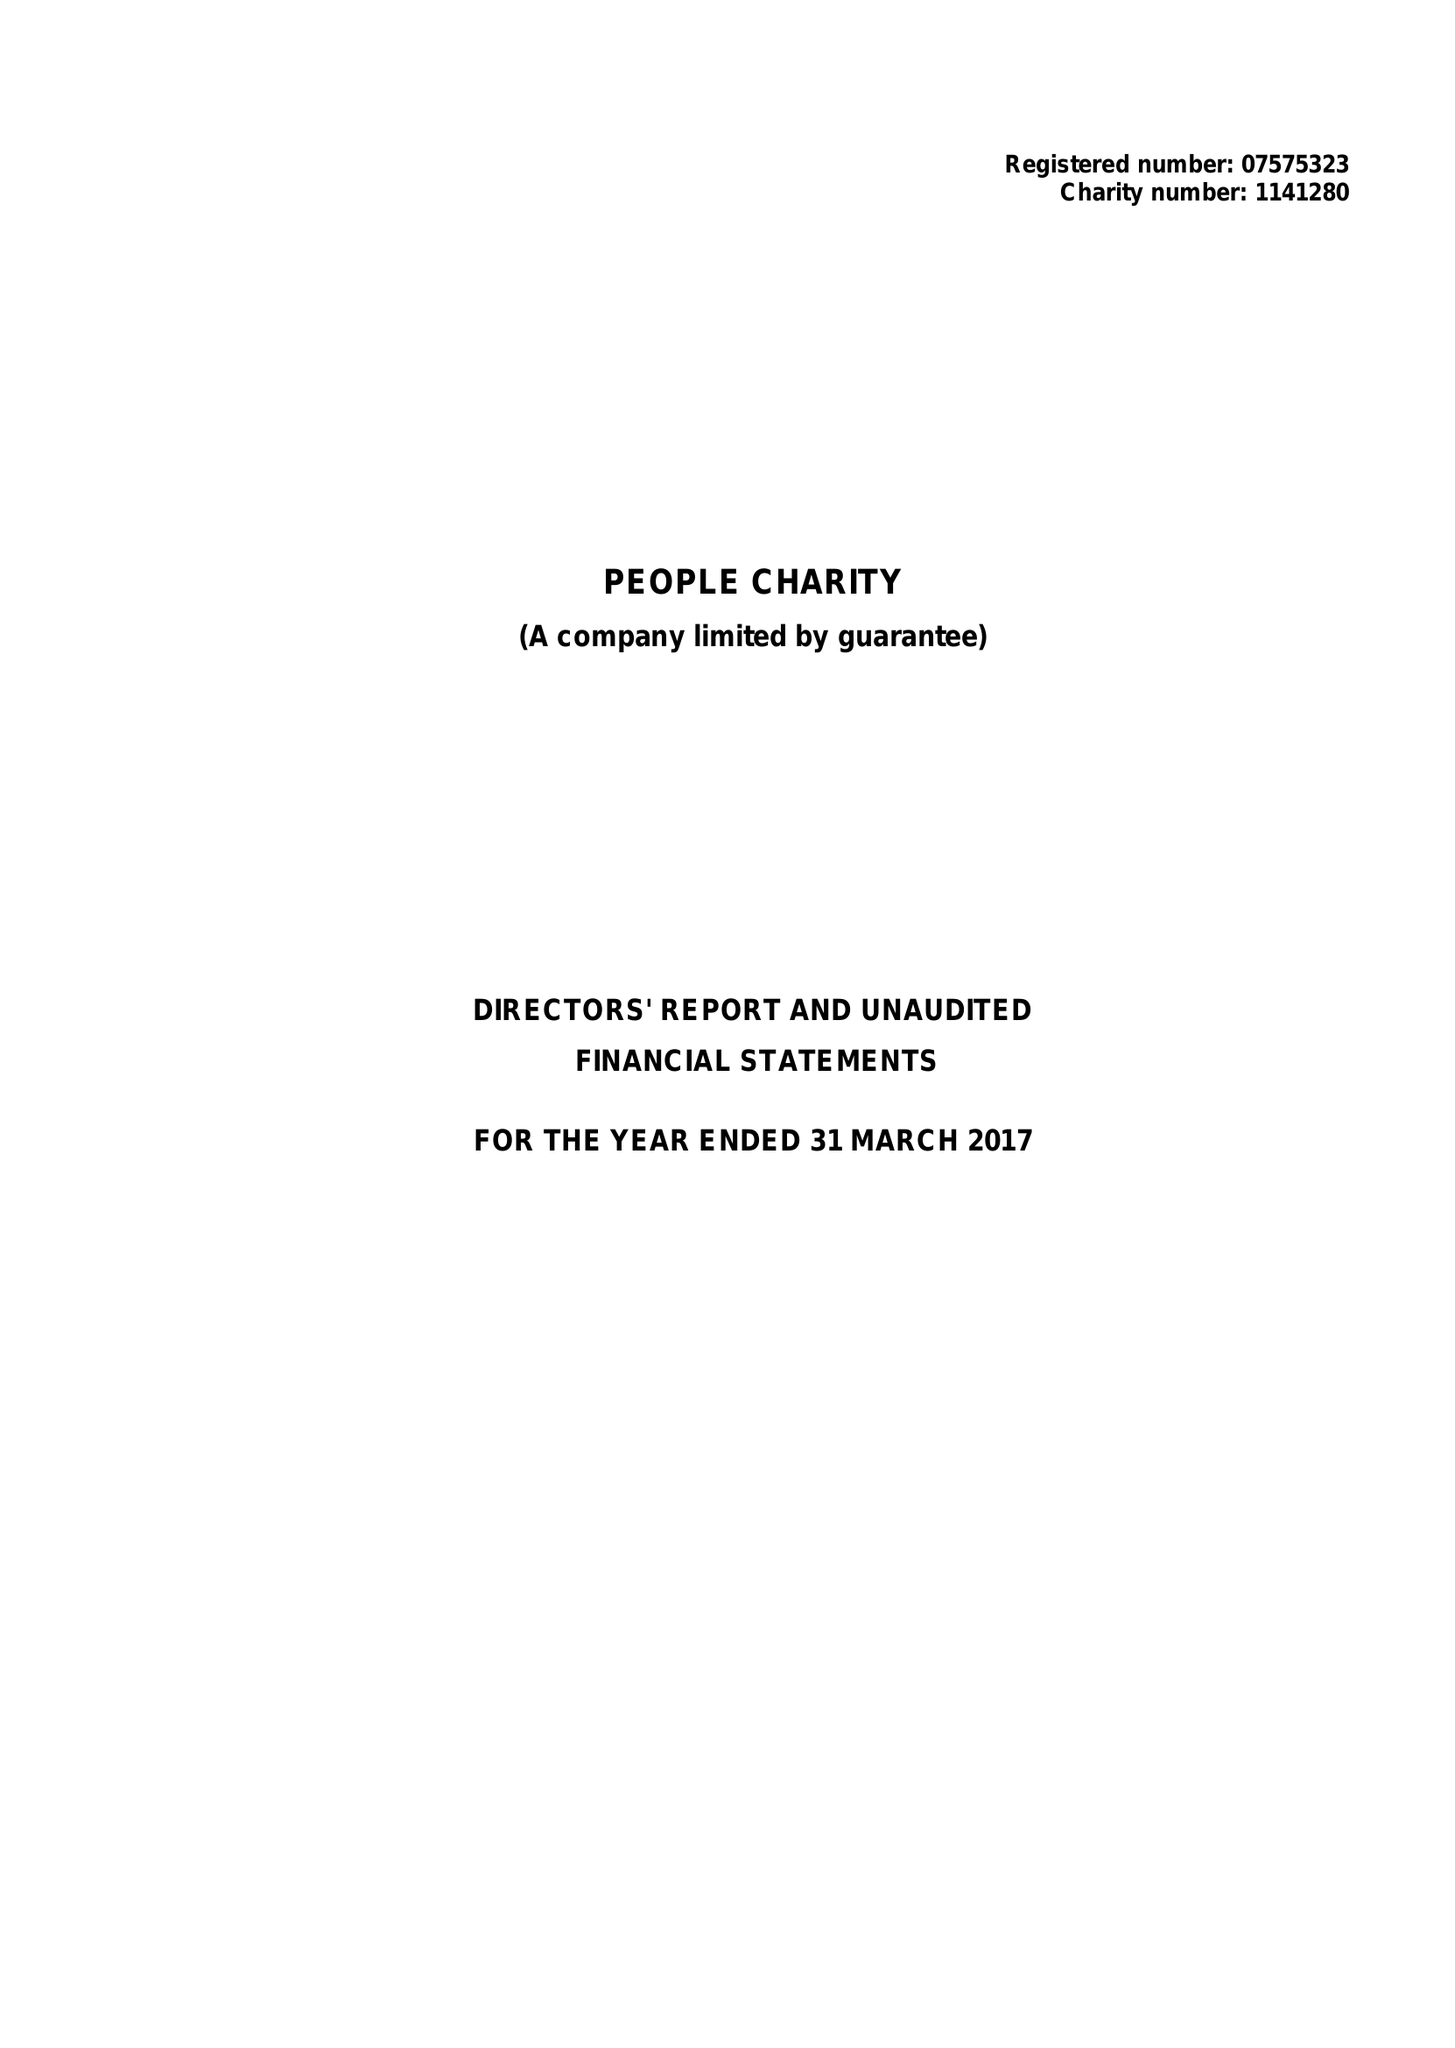What is the value for the charity_number?
Answer the question using a single word or phrase. 1141280 